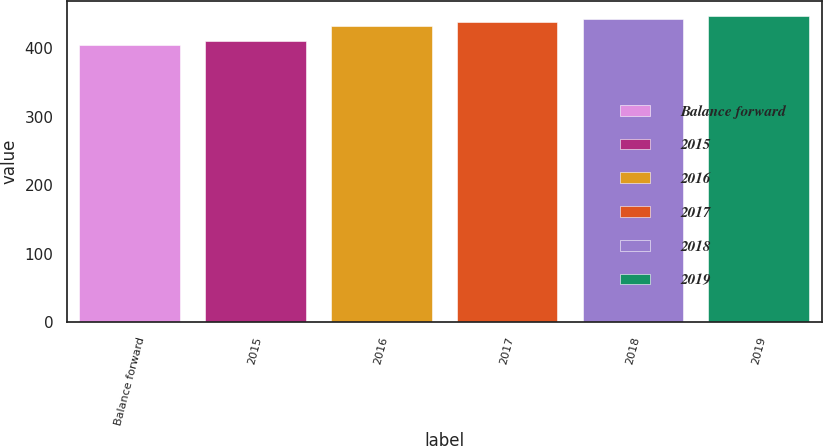Convert chart to OTSL. <chart><loc_0><loc_0><loc_500><loc_500><bar_chart><fcel>Balance forward<fcel>2015<fcel>2016<fcel>2017<fcel>2018<fcel>2019<nl><fcel>405<fcel>411<fcel>432<fcel>439<fcel>443<fcel>446.8<nl></chart> 